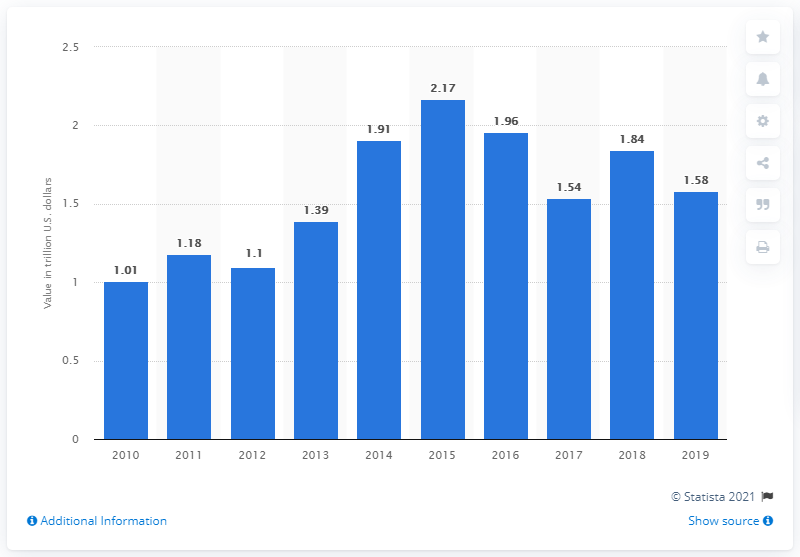Outline some significant characteristics in this image. In 2019, the value of mergers and acquisitions (M&A) deals in North America totaled 1.58 trillion dollars. 